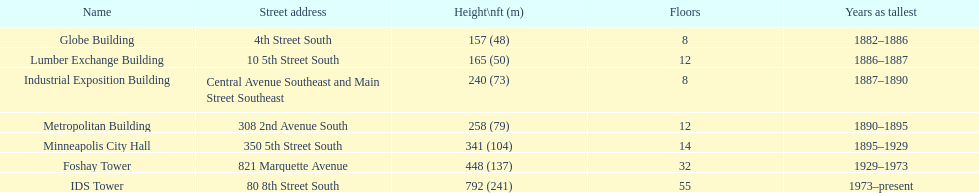After ids tower what is the second tallest building in minneapolis? Foshay Tower. 